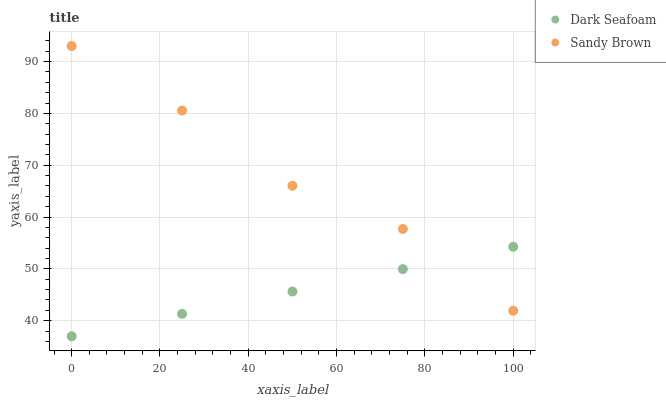Does Dark Seafoam have the minimum area under the curve?
Answer yes or no. Yes. Does Sandy Brown have the maximum area under the curve?
Answer yes or no. Yes. Does Sandy Brown have the minimum area under the curve?
Answer yes or no. No. Is Dark Seafoam the smoothest?
Answer yes or no. Yes. Is Sandy Brown the roughest?
Answer yes or no. Yes. Is Sandy Brown the smoothest?
Answer yes or no. No. Does Dark Seafoam have the lowest value?
Answer yes or no. Yes. Does Sandy Brown have the lowest value?
Answer yes or no. No. Does Sandy Brown have the highest value?
Answer yes or no. Yes. Does Dark Seafoam intersect Sandy Brown?
Answer yes or no. Yes. Is Dark Seafoam less than Sandy Brown?
Answer yes or no. No. Is Dark Seafoam greater than Sandy Brown?
Answer yes or no. No. 